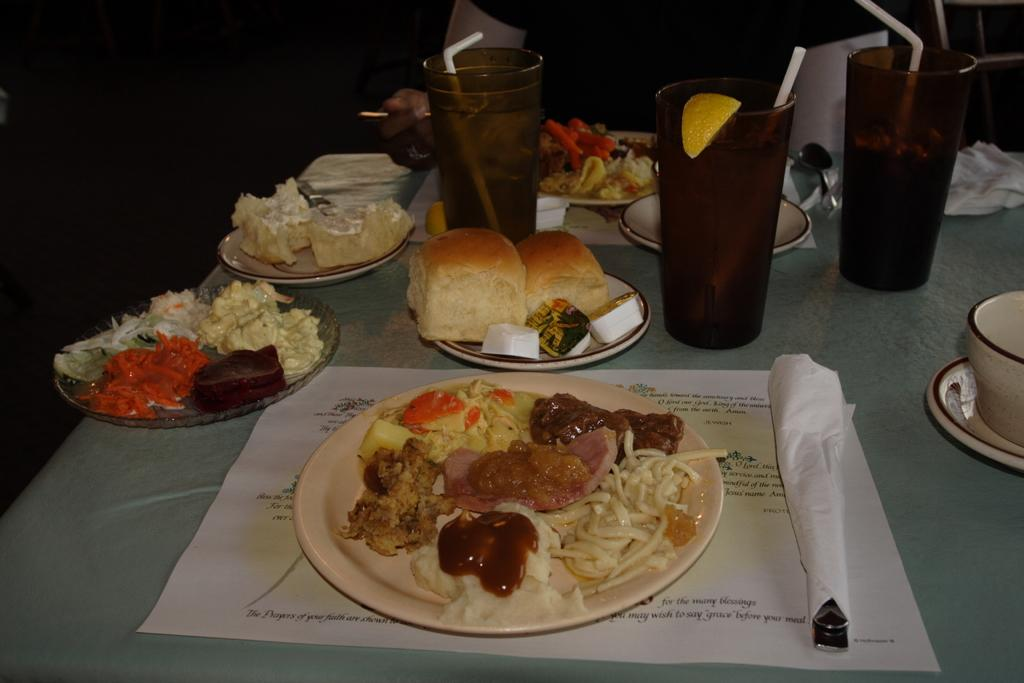What can be seen on the plates in the image? There are food items on plates in the image. What else is present on the table besides the plates? There are glasses in the image. Can you describe the person in the background of the image? Unfortunately, the facts provided do not give any details about the person in the background. What type of sticks are being used to play music in the image? There are no sticks or musical instruments present in the image. Can you describe the pig that is sitting next to the person in the image? There is no pig present in the image; only food items, plates, and glasses are visible. 